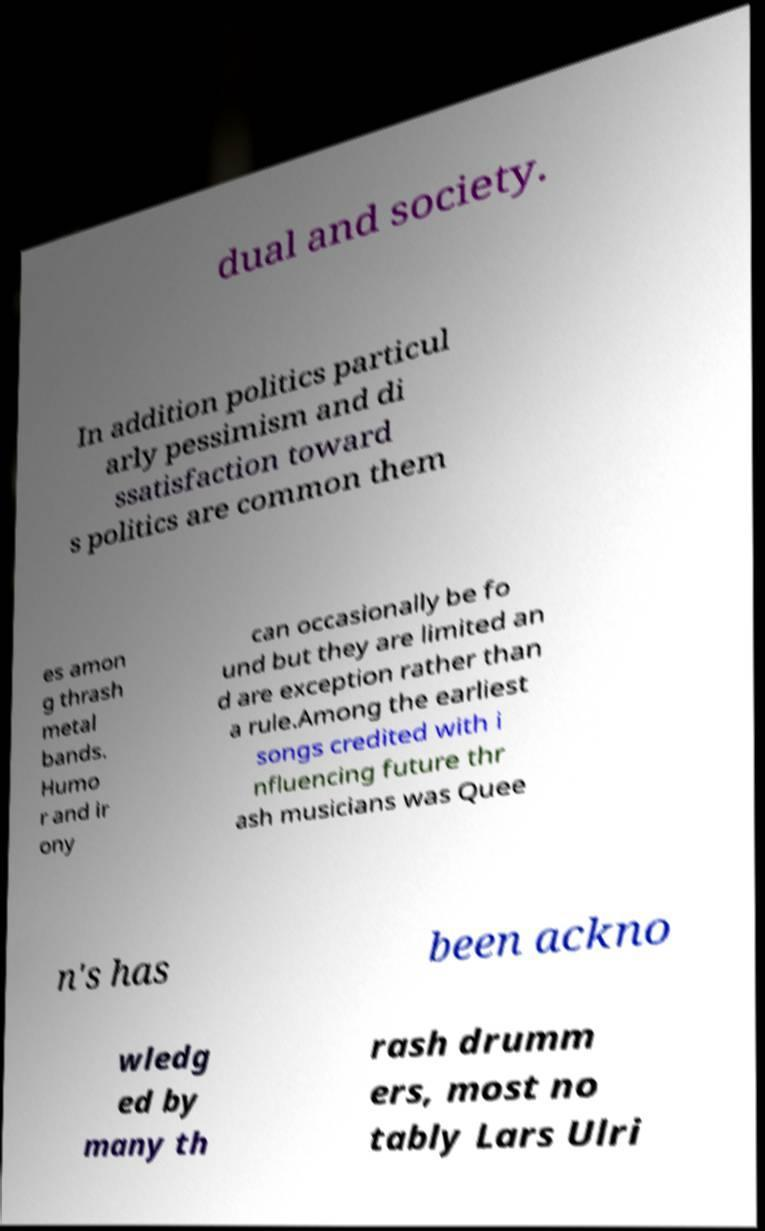What messages or text are displayed in this image? I need them in a readable, typed format. dual and society. In addition politics particul arly pessimism and di ssatisfaction toward s politics are common them es amon g thrash metal bands. Humo r and ir ony can occasionally be fo und but they are limited an d are exception rather than a rule.Among the earliest songs credited with i nfluencing future thr ash musicians was Quee n's has been ackno wledg ed by many th rash drumm ers, most no tably Lars Ulri 